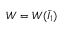Convert formula to latex. <formula><loc_0><loc_0><loc_500><loc_500>W = W ( { \bar { I } } _ { 1 } )</formula> 